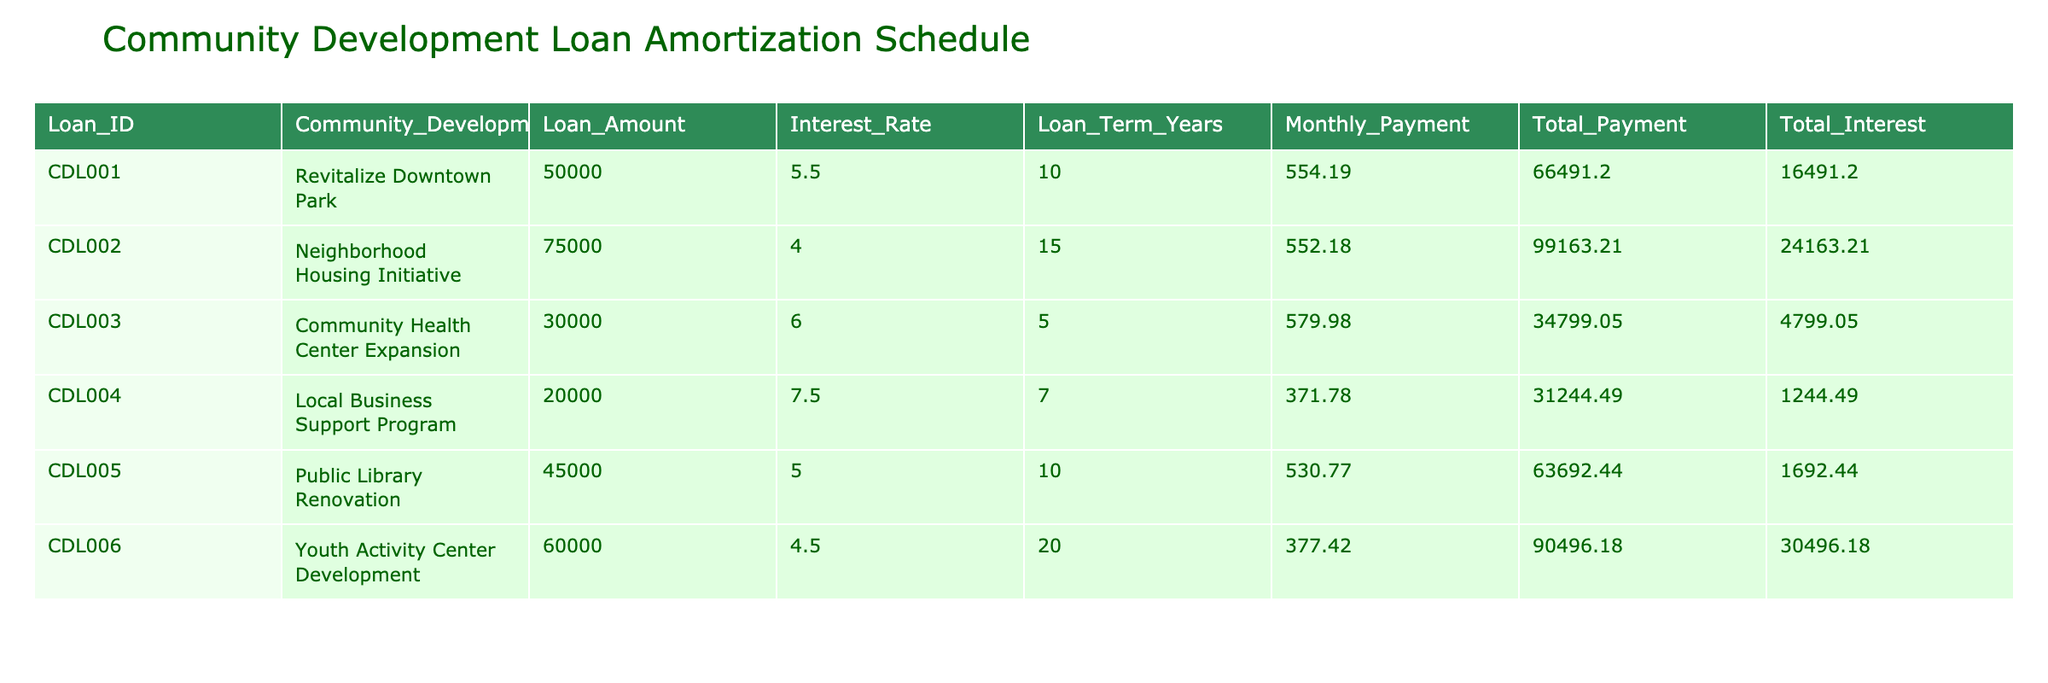What is the loan amount for the "Neighborhood Housing Initiative"? The "Neighborhood Housing Initiative" has a loan amount listed in the table; by checking that specific row, we find it is 75000.
Answer: 75000 What is the total interest paid for the "Public Library Renovation"? The total interest for the "Public Library Renovation" can be found in its corresponding row in the table, which is 1692.44.
Answer: 1692.44 Which project has the lowest monthly payment? By examining the "Monthly Payment" column for all projects, we identify the lowest value, which corresponds to the "Local Business Support Program" with a monthly payment of 371.78.
Answer: 371.78 How much total payment will be made for the "Community Health Center Expansion"? The total payment for the "Community Health Center Expansion" is listed directly in its row. Referring to that row, we see it is 34799.05.
Answer: 34799.05 Is there a project with a loan term longer than 15 years? By reviewing the "Loan Term Years" column, we find that all values are either 10, 15, 5, 7, or 20 years. Since one entry is 20 years, the answer is true.
Answer: Yes What is the average interest rate for all listed projects? To determine the average interest rate, we add up all the interest rates: 5.5 + 4.0 + 6.0 + 7.5 + 5.0 + 4.5 = 32.5. Then, we divide by the number of projects, which is 6, leading to an average of 32.5/6 = 5.42.
Answer: 5.42 Which project has the highest total payment? Looking through the "Total Payment" column, we see that the "Neighborhood Housing Initiative" has the highest total payment, amounting to 99163.21.
Answer: 99163.21 What is the difference between the loan amount of the "Youth Activity Center Development" and the "Local Business Support Program"? The loan amount for the "Youth Activity Center Development" is 60000, and for the "Local Business Support Program," it is 20000. The difference is 60000 - 20000 = 40000.
Answer: 40000 Is the monthly payment for the "Revitalize Downtown Park" higher than the monthly payment for the "Public Library Renovation"? The monthly payments are 554.19 for "Revitalize Downtown Park" and 530.77 for "Public Library Renovation." Since 554.19 is greater than 530.77, the answer is true.
Answer: Yes 